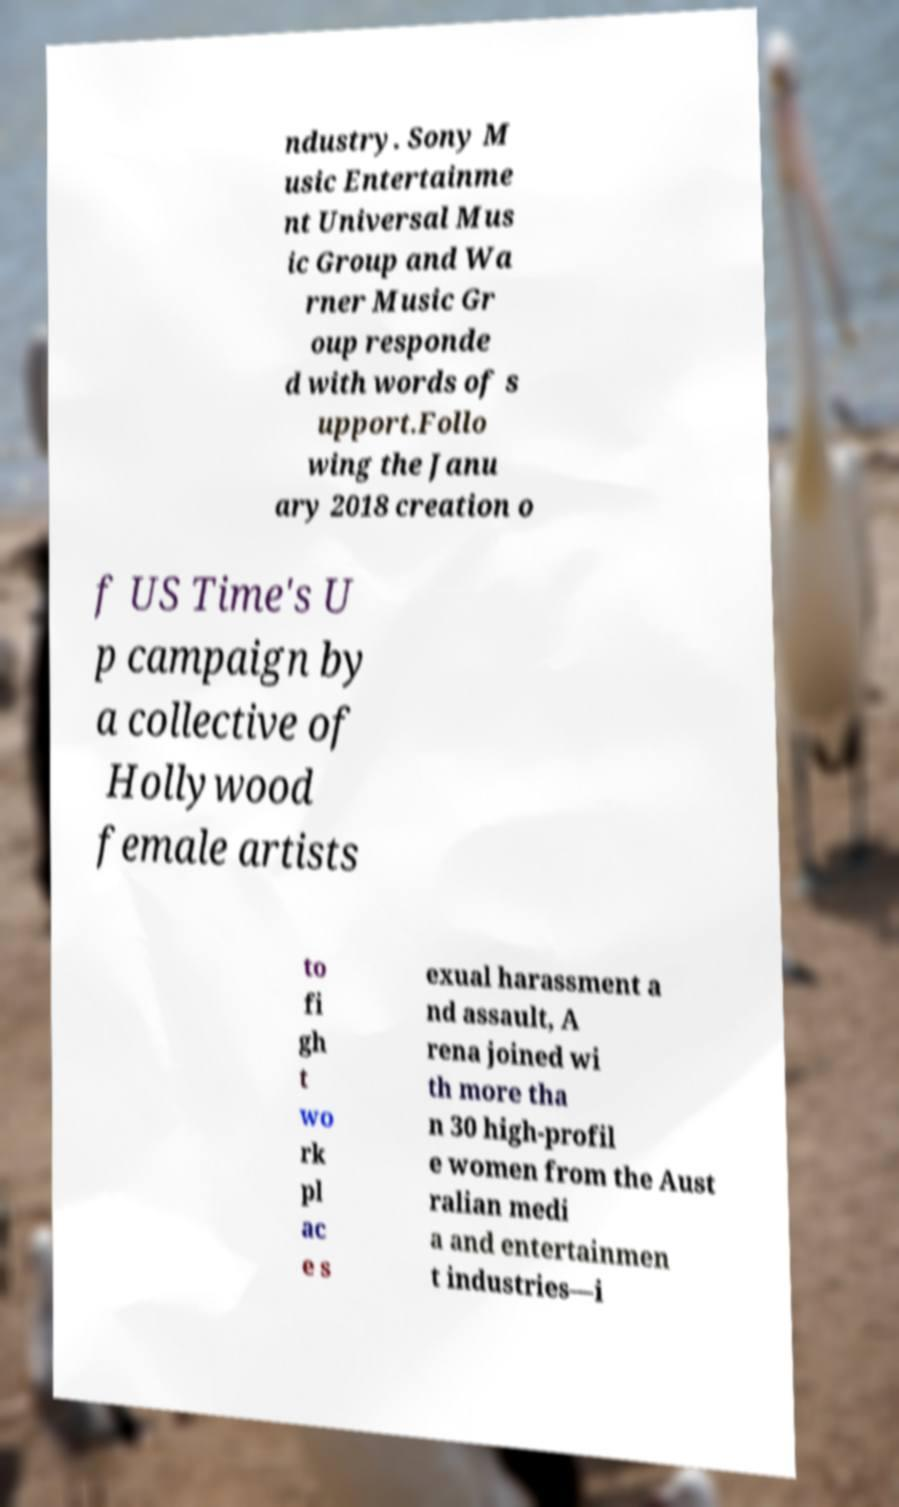Please read and relay the text visible in this image. What does it say? ndustry. Sony M usic Entertainme nt Universal Mus ic Group and Wa rner Music Gr oup responde d with words of s upport.Follo wing the Janu ary 2018 creation o f US Time's U p campaign by a collective of Hollywood female artists to fi gh t wo rk pl ac e s exual harassment a nd assault, A rena joined wi th more tha n 30 high-profil e women from the Aust ralian medi a and entertainmen t industries—i 